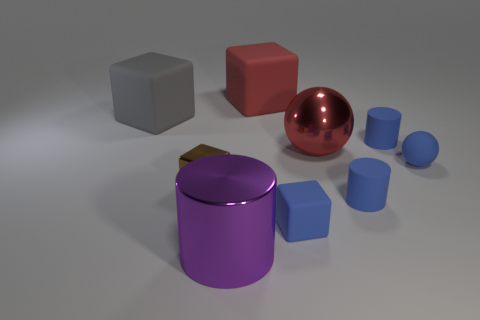Are there more big metal cylinders right of the small rubber sphere than balls on the left side of the brown thing?
Give a very brief answer. No. What number of other things are the same shape as the purple metal thing?
Provide a short and direct response. 2. There is a cylinder that is on the left side of the small blue matte block; are there any large red things left of it?
Offer a very short reply. No. What number of tiny rubber balls are there?
Offer a very short reply. 1. Does the big metal sphere have the same color as the cylinder behind the blue matte ball?
Make the answer very short. No. Is the number of tiny cyan matte things greater than the number of large spheres?
Offer a terse response. No. Is there any other thing that is the same color as the rubber ball?
Your response must be concise. Yes. What number of other objects are there of the same size as the brown metallic block?
Provide a succinct answer. 4. What material is the big thing on the right side of the block that is right of the big rubber thing right of the big purple object?
Offer a terse response. Metal. Does the large sphere have the same material as the tiny blue cylinder that is behind the blue sphere?
Your response must be concise. No. 